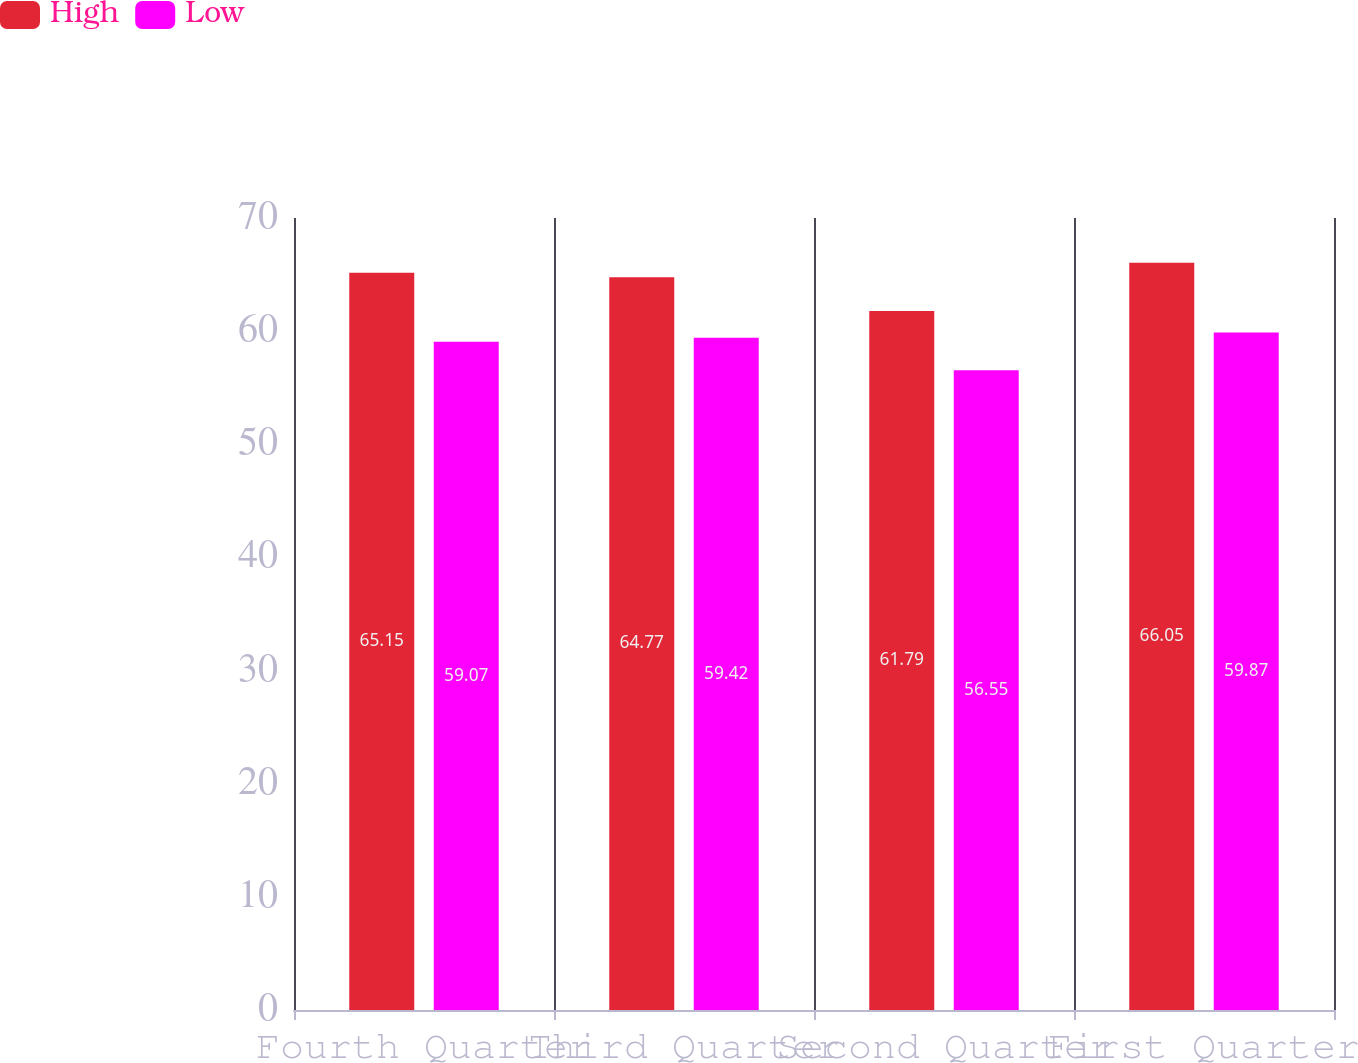<chart> <loc_0><loc_0><loc_500><loc_500><stacked_bar_chart><ecel><fcel>Fourth Quarter<fcel>Third Quarter<fcel>Second Quarter<fcel>First Quarter<nl><fcel>High<fcel>65.15<fcel>64.77<fcel>61.79<fcel>66.05<nl><fcel>Low<fcel>59.07<fcel>59.42<fcel>56.55<fcel>59.87<nl></chart> 